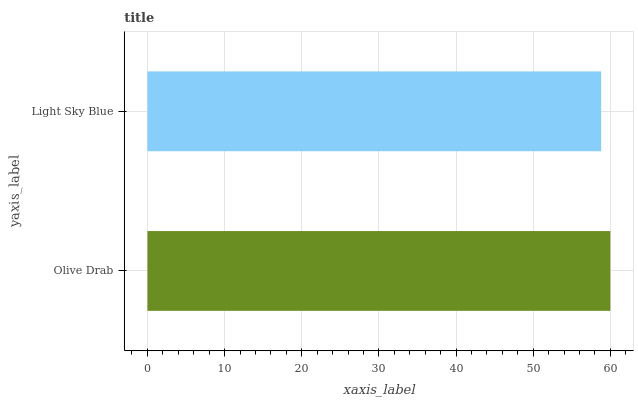Is Light Sky Blue the minimum?
Answer yes or no. Yes. Is Olive Drab the maximum?
Answer yes or no. Yes. Is Light Sky Blue the maximum?
Answer yes or no. No. Is Olive Drab greater than Light Sky Blue?
Answer yes or no. Yes. Is Light Sky Blue less than Olive Drab?
Answer yes or no. Yes. Is Light Sky Blue greater than Olive Drab?
Answer yes or no. No. Is Olive Drab less than Light Sky Blue?
Answer yes or no. No. Is Olive Drab the high median?
Answer yes or no. Yes. Is Light Sky Blue the low median?
Answer yes or no. Yes. Is Light Sky Blue the high median?
Answer yes or no. No. Is Olive Drab the low median?
Answer yes or no. No. 